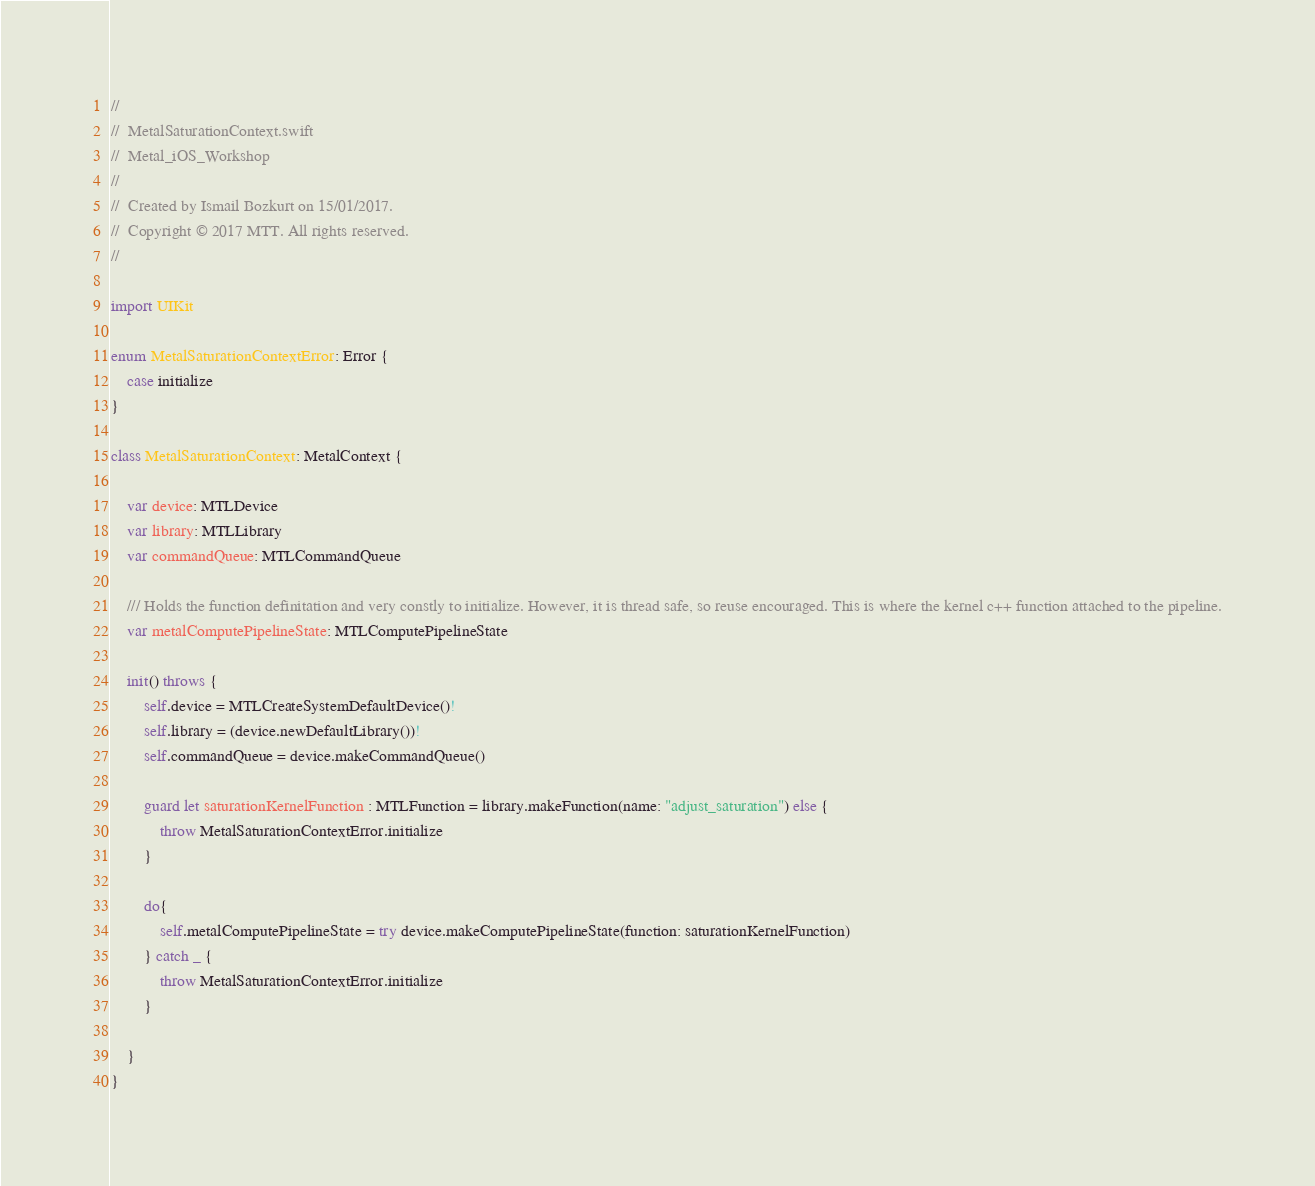<code> <loc_0><loc_0><loc_500><loc_500><_Swift_>//
//  MetalSaturationContext.swift
//  Metal_iOS_Workshop
//
//  Created by Ismail Bozkurt on 15/01/2017.
//  Copyright © 2017 MTT. All rights reserved.
//

import UIKit

enum MetalSaturationContextError: Error {
    case initialize
}

class MetalSaturationContext: MetalContext {
    
    var device: MTLDevice
    var library: MTLLibrary
    var commandQueue: MTLCommandQueue
    
    /// Holds the function definitation and very constly to initialize. However, it is thread safe, so reuse encouraged. This is where the kernel c++ function attached to the pipeline.
    var metalComputePipelineState: MTLComputePipelineState
    
    init() throws {
        self.device = MTLCreateSystemDefaultDevice()!
        self.library = (device.newDefaultLibrary())!
        self.commandQueue = device.makeCommandQueue()
        
        guard let saturationKernelFunction : MTLFunction = library.makeFunction(name: "adjust_saturation") else {
            throw MetalSaturationContextError.initialize
        }
        
        do{
            self.metalComputePipelineState = try device.makeComputePipelineState(function: saturationKernelFunction)
        } catch _ {
            throw MetalSaturationContextError.initialize
        }
        
    }
}
</code> 